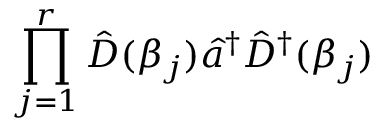Convert formula to latex. <formula><loc_0><loc_0><loc_500><loc_500>\prod _ { j = 1 } ^ { r } \hat { D } ( \beta _ { j } ) \hat { a } ^ { \dagger } \hat { D } ^ { \dagger } ( \beta _ { j } )</formula> 